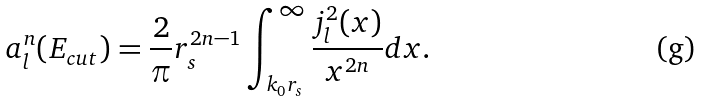Convert formula to latex. <formula><loc_0><loc_0><loc_500><loc_500>a _ { l } ^ { n } ( E _ { c u t } ) = \frac { 2 } { \pi } r _ { s } ^ { 2 n - 1 } \int _ { k _ { 0 } r _ { s } } ^ { \infty } \frac { j _ { l } ^ { 2 } ( x ) } { x ^ { 2 n } } d x .</formula> 